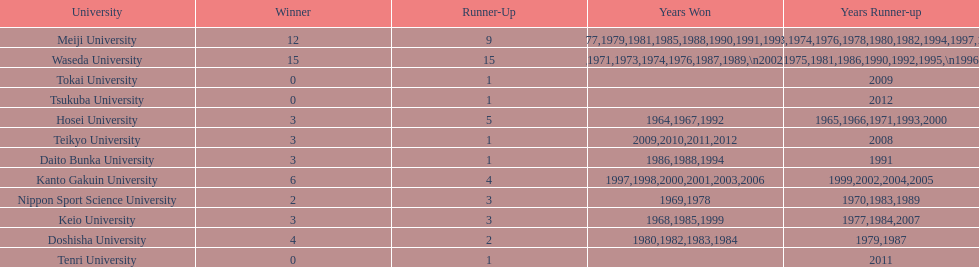Who won the last championship recorded on this table? Teikyo University. 